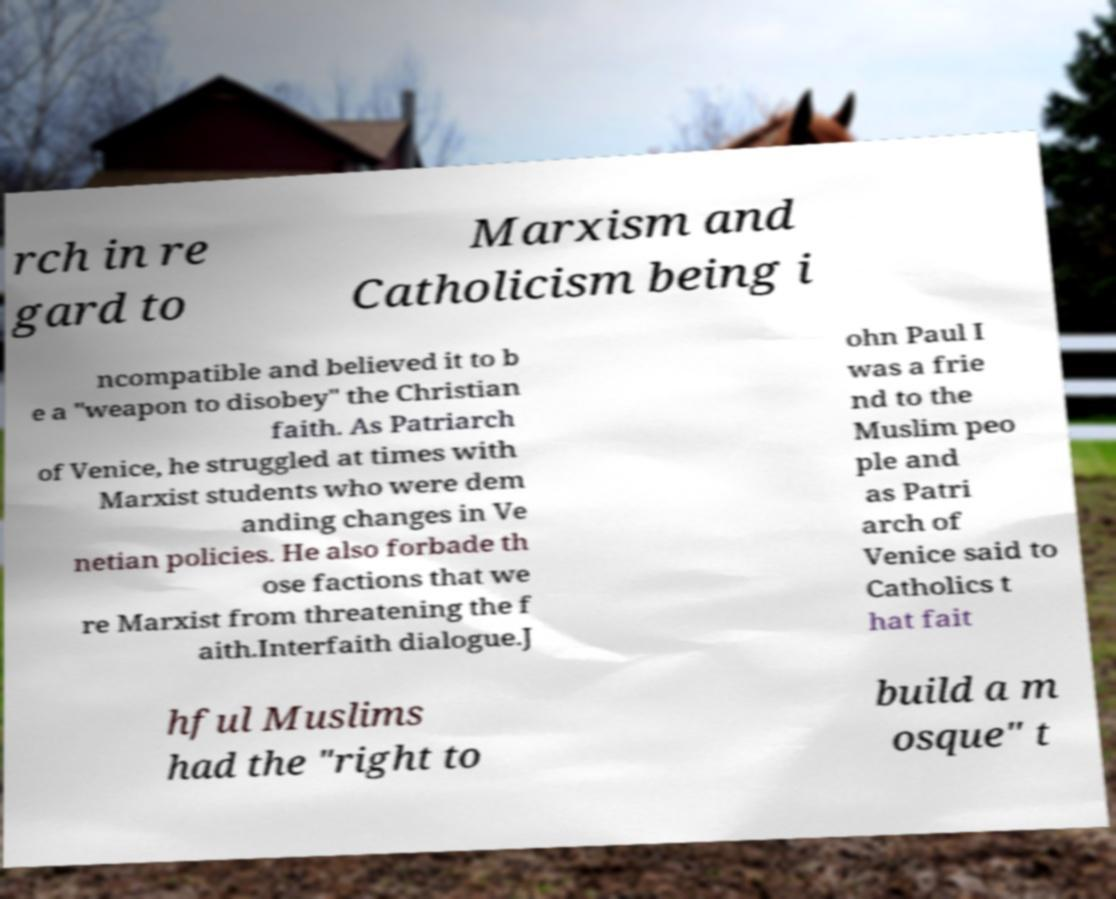I need the written content from this picture converted into text. Can you do that? rch in re gard to Marxism and Catholicism being i ncompatible and believed it to b e a "weapon to disobey" the Christian faith. As Patriarch of Venice, he struggled at times with Marxist students who were dem anding changes in Ve netian policies. He also forbade th ose factions that we re Marxist from threatening the f aith.Interfaith dialogue.J ohn Paul I was a frie nd to the Muslim peo ple and as Patri arch of Venice said to Catholics t hat fait hful Muslims had the "right to build a m osque" t 